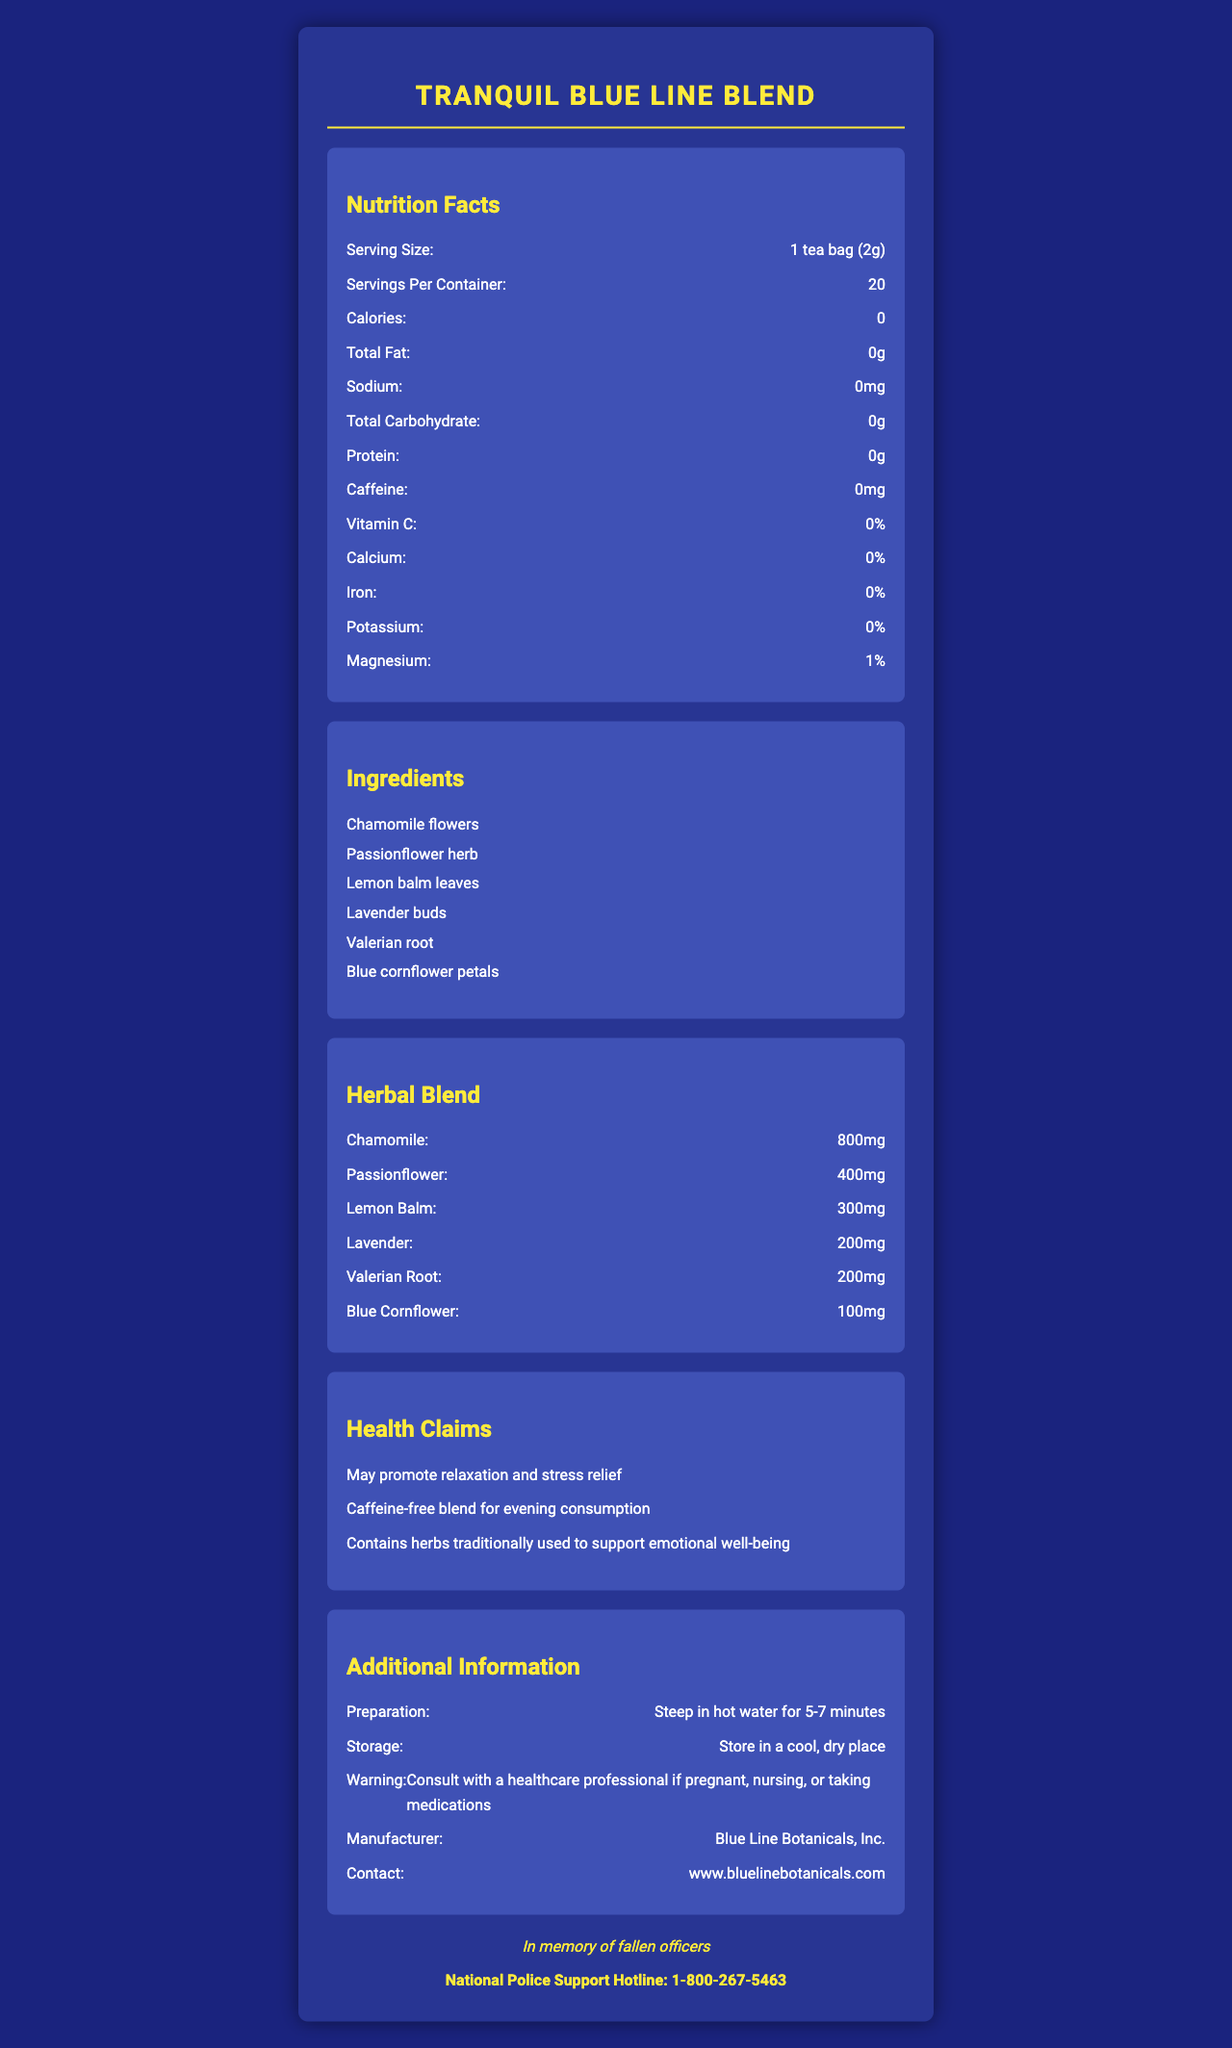what is the serving size for Tranquil Blue Line Blend? The nutrition facts section lists the serving size as "1 tea bag (2g)".
Answer: 1 tea bag (2g) how many servings are there per container? The nutrition facts section indicates that there are 20 servings per container.
Answer: 20 how many calories are in each serving? The nutrition facts list "0" calories per serving.
Answer: 0 what are the main ingredients in the Tranquil Blue Line Blend? The ingredients section lists these components as the main ingredients.
Answer: Chamomile flowers, Passionflower herb, Lemon balm leaves, Lavender buds, Valerian root, Blue cornflower petals are there any vitamins or minerals in this blend? The nutrition facts section shows that there is 1% Magnesium in the blend. Other vitamins and minerals are listed as 0%.
Answer: Yes, Magnesium what is the recommended steeping time for this tea? The preparation section indicates that the tea should be steeped in hot water for 5-7 minutes.
Answer: 5-7 minutes which herb has the largest proportion in the herbal blend? The herbal blend section shows that chamomile has the highest amount at 800mg.
Answer: Chamomile what is the sodium content in this tea? According to the nutrition facts section, the sodium content is "0mg".
Answer: 0mg is this tea blend caffeine-free? (True/False) The nutrition facts document lists "Caffeine: 0mg" which means it is caffeine-free.
Answer: True which of the following herbs is NOT included in the Tranquil Blue Line Blend? A. Peppermint B. Chamomile C. Lemon Balm D. Lavender The ingredients and herbal blend sections do not include peppermint among the listed ingredients.
Answer: A. Peppermint what is the magnesium percentage in each serving? A. 0% B. 1% C. 2% D. 5% The document lists magnesium as 1% in the nutrition facts section.
Answer: B. 1% what health claim does NOT apply to this tea? A. May promote relaxation and stress relief B. High in protein for muscle recovery C. Contains herbs traditionally used to support emotional well-being The health claims indicated are associated with relaxation, stress relief, and emotional well-being, none of which mention muscle recovery or protein content.
Answer: B. High in protein for muscle recovery what storage conditions are recommended for Tranquil Blue Line Blend? The storage section advises keeping the tea in a cool, dry place.
Answer: Store in a cool, dry place what should individuals consult with if they are pregnant, nursing, or taking medications? The warning section suggests consulting with a healthcare professional in such cases.
Answer: A healthcare professional who manufactures Tranquil Blue Line Blend? The additional information section lists the manufacturer as Blue Line Botanicals, Inc.
Answer: Blue Line Botanicals, Inc. summarize the key points of the Tranquil Blue Line Blend nutrition facts label. The document provides detailed nutritional information, ingredient lists, health claims, preparation and storage guidelines, and warnings, emphasizing its use for stress relief and emotional well-being.
Answer: The Tranquil Blue Line Blend is a caffeine-free herbal tea designed for stress relief and relaxation. One serving size is 1 tea bag (2g) with 20 servings per container. It has 0 calories and contains an herbal blend including chamomile, passionflower, lemon balm, lavender, valerian root, and blue cornflower petals. It is dedicated to fallen officers and provides support information for the National Police Support Hotline. what is the total carbohydrate content per serving? The nutrition facts section indicates a total carbohydrate content of "0g".
Answer: 0g which website provides more information about Blue Line Botanicals? The contact information section lists this website.
Answer: www.bluelinebotanicals.com why is there a dedication on the label? The document expressly states that the blend is dedicated to the memory of fallen officers.
Answer: In memory of fallen officers what is the National Police Support Hotline number? This contact information is provided at the end of the document.
Answer: 1-800-267-5463 what are the protein and iron contents in a serving of this tea? The nutrition facts section lists protein content as "0g" and iron content as "0%".
Answer: Protein: 0g; Iron: 0% what is the main idea of the document? The document includes various sections describing the tea's nutritional content, ingredient specifics, health claims, and intended use for stress relief.
Answer: The document provides detailed nutritional information, ingredients, health benefits, and preparation instructions for the Tranquil Blue Line Blend herbal tea, emphasizing its calming, caffeine-free qualities intended for stress relief and relaxation. what does Blue Line Botanicals' contact information include? The document specifies the website (www.bluelinebotanicals.com) but does not provide any other contact details such as an email address or phone number.
Answer: Cannot be determined 